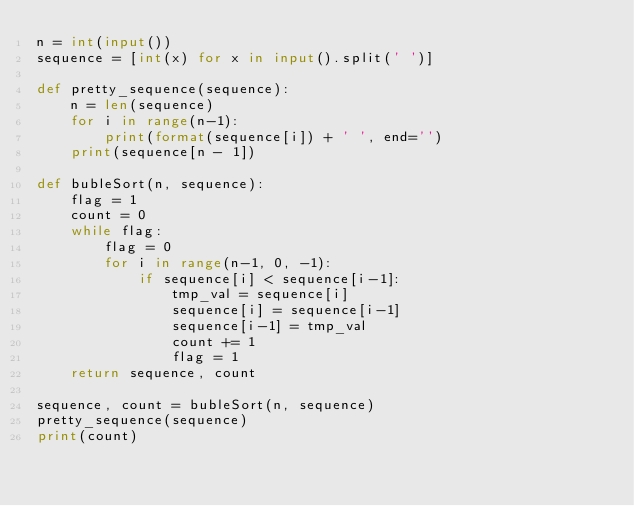Convert code to text. <code><loc_0><loc_0><loc_500><loc_500><_Python_>n = int(input())
sequence = [int(x) for x in input().split(' ')]

def pretty_sequence(sequence):
    n = len(sequence)
    for i in range(n-1):
        print(format(sequence[i]) + ' ', end='')
    print(sequence[n - 1])

def bubleSort(n, sequence):
    flag = 1
    count = 0
    while flag:
        flag = 0
        for i in range(n-1, 0, -1):
            if sequence[i] < sequence[i-1]:
                tmp_val = sequence[i]
                sequence[i] = sequence[i-1]
                sequence[i-1] = tmp_val
                count += 1
                flag = 1
    return sequence, count

sequence, count = bubleSort(n, sequence)
pretty_sequence(sequence)
print(count)</code> 